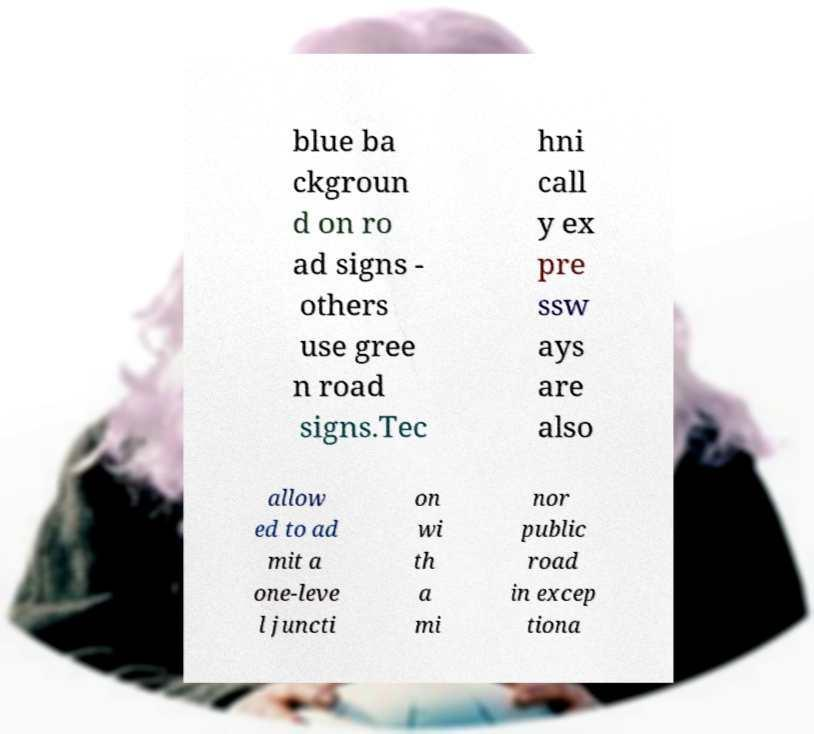Can you accurately transcribe the text from the provided image for me? blue ba ckgroun d on ro ad signs - others use gree n road signs.Tec hni call y ex pre ssw ays are also allow ed to ad mit a one-leve l juncti on wi th a mi nor public road in excep tiona 